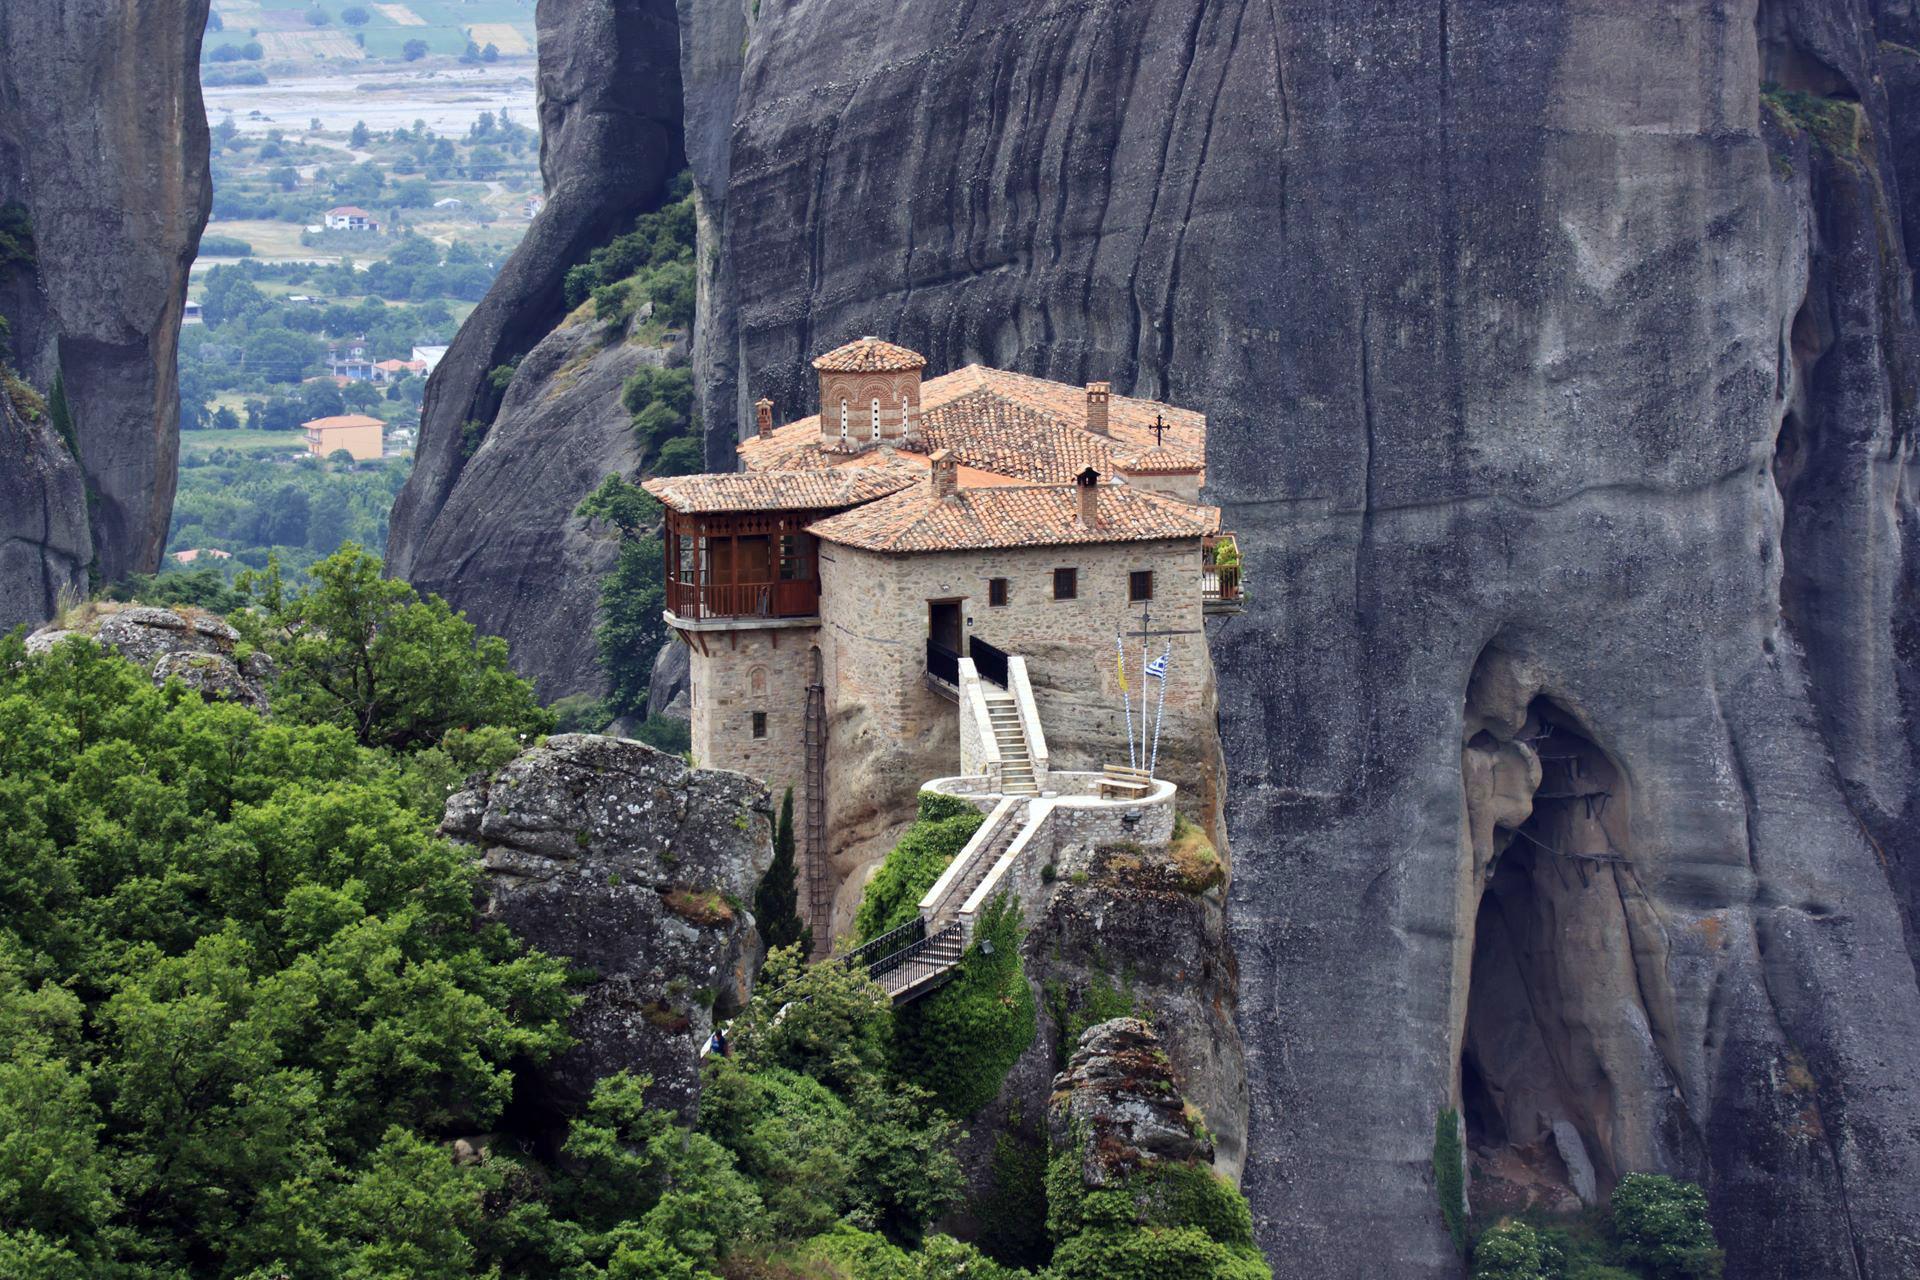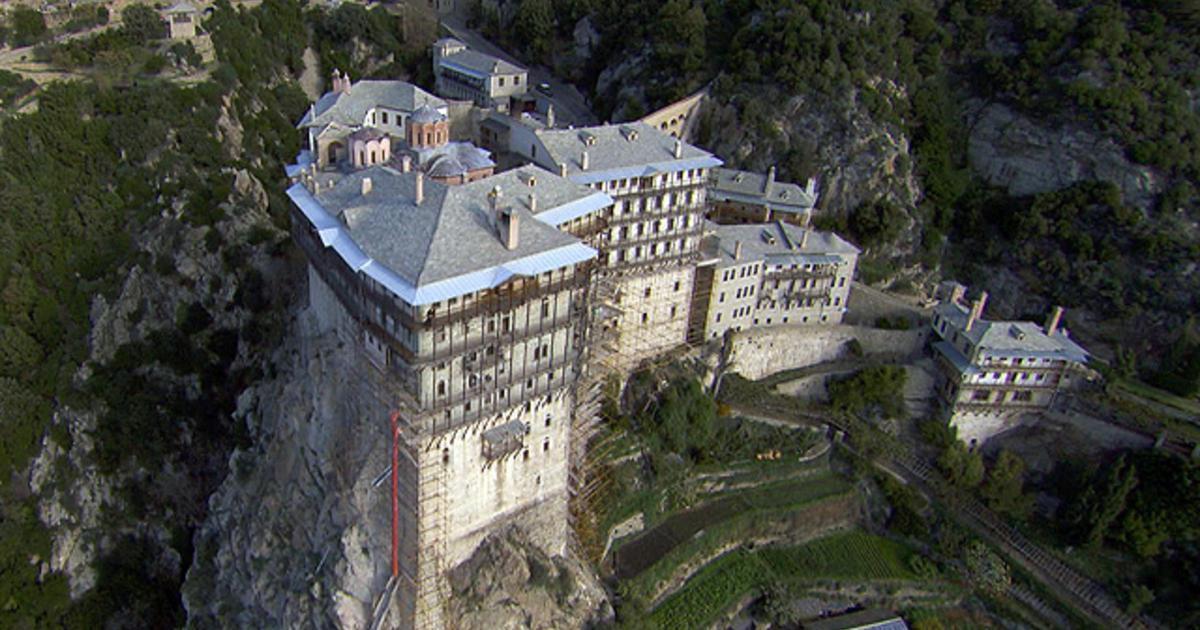The first image is the image on the left, the second image is the image on the right. For the images shown, is this caption "Terraced steps with greenery lead up to a series of squarish buildings with neutral-colored roofs in one image." true? Answer yes or no. Yes. The first image is the image on the left, the second image is the image on the right. Evaluate the accuracy of this statement regarding the images: "Cliffs can be seen behind the castle on the left.". Is it true? Answer yes or no. Yes. 